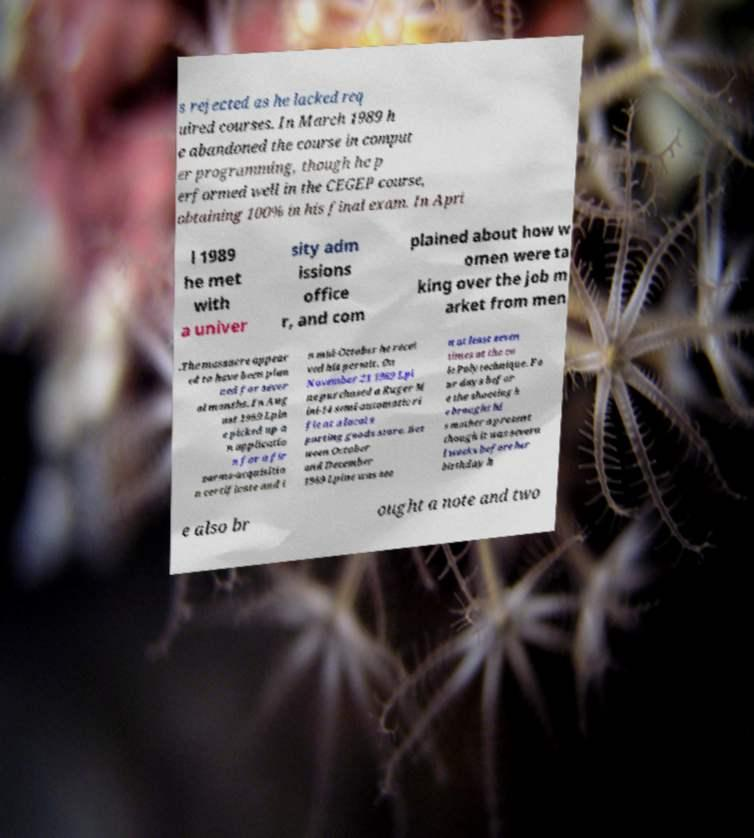Could you assist in decoding the text presented in this image and type it out clearly? s rejected as he lacked req uired courses. In March 1989 h e abandoned the course in comput er programming, though he p erformed well in the CEGEP course, obtaining 100% in his final exam. In Apri l 1989 he met with a univer sity adm issions office r, and com plained about how w omen were ta king over the job m arket from men .The massacre appear ed to have been plan ned for sever al months. In Aug ust 1989 Lpin e picked up a n applicatio n for a fir earms-acquisitio n certificate and i n mid-October he recei ved his permit. On November 21 1989 Lpi ne purchased a Ruger M ini-14 semi-automatic ri fle at a local s porting goods store. Bet ween October and December 1989 Lpine was see n at least seven times at the co le Polytechnique. Fo ur days befor e the shooting h e brought hi s mother a present though it was severa l weeks before her birthday h e also br ought a note and two 